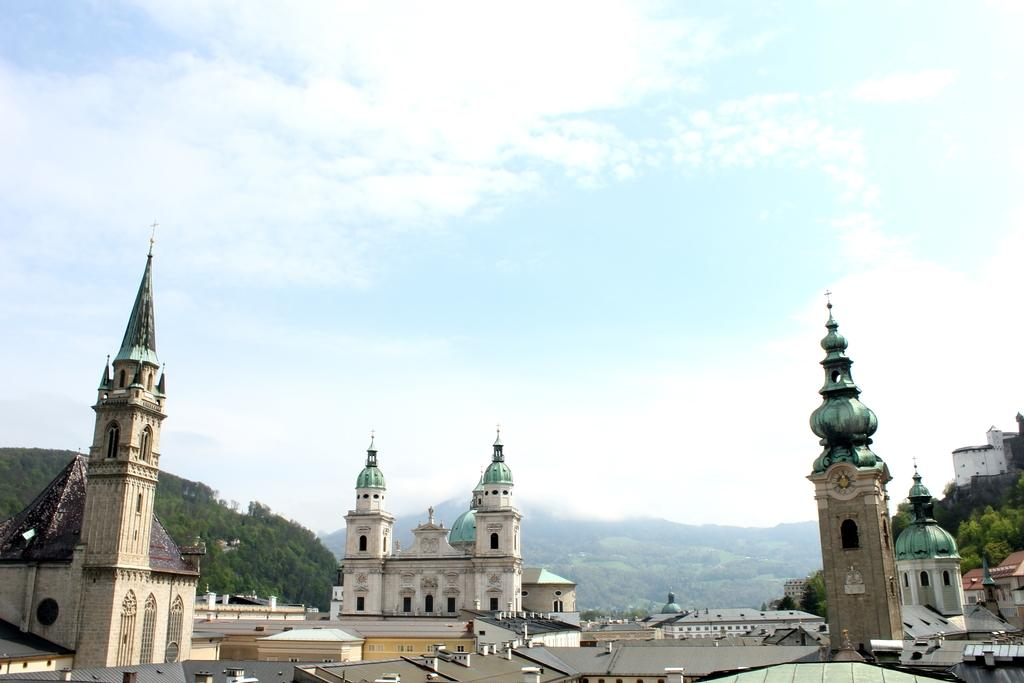What structures are present in the image? There are buildings in the image. What type of natural vegetation is visible in the image? There are trees in the image. What geographical features can be seen in the background of the image? There are mountains visible in the background of the image. What part of the natural environment is visible in the image? The sky is visible in the background of the image. Where is the cushion located in the image? There is no cushion present in the image. What type of rod can be seen holding up the mountains in the image? There is no rod present in the image, and the mountains are not held up by any such object. 